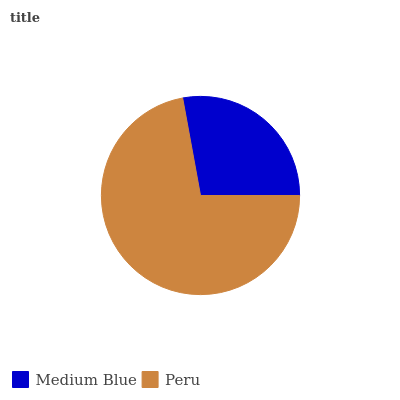Is Medium Blue the minimum?
Answer yes or no. Yes. Is Peru the maximum?
Answer yes or no. Yes. Is Peru the minimum?
Answer yes or no. No. Is Peru greater than Medium Blue?
Answer yes or no. Yes. Is Medium Blue less than Peru?
Answer yes or no. Yes. Is Medium Blue greater than Peru?
Answer yes or no. No. Is Peru less than Medium Blue?
Answer yes or no. No. Is Peru the high median?
Answer yes or no. Yes. Is Medium Blue the low median?
Answer yes or no. Yes. Is Medium Blue the high median?
Answer yes or no. No. Is Peru the low median?
Answer yes or no. No. 